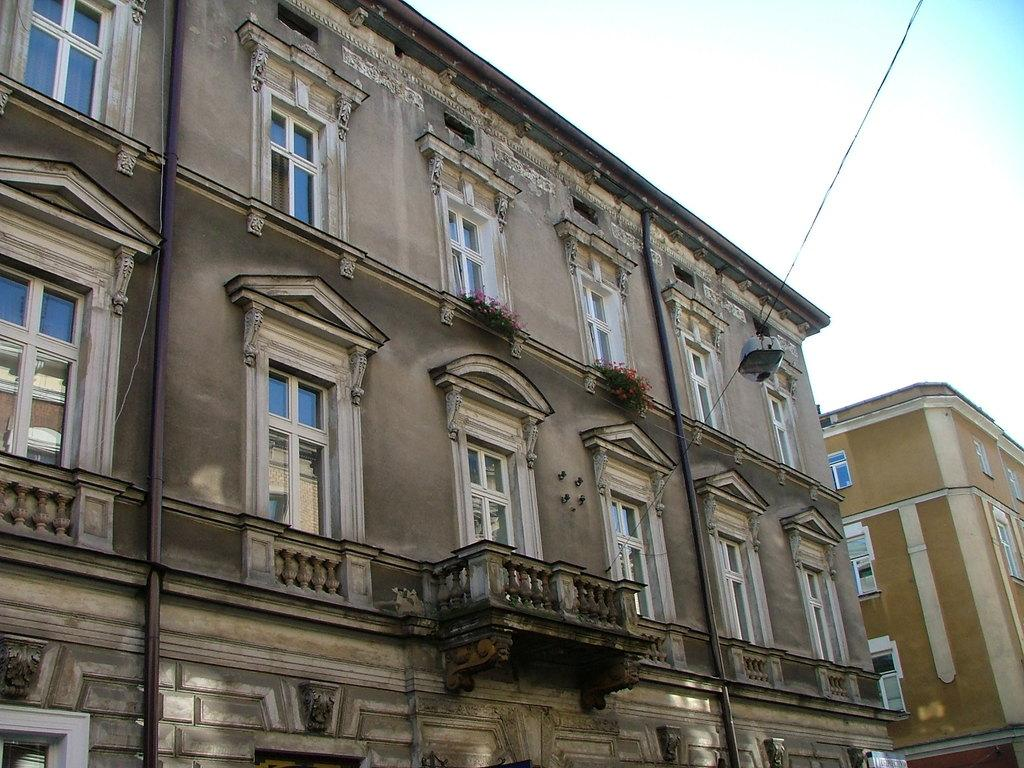What type of structures can be seen in the image? There are buildings in the image. What colors are the buildings? The buildings are in brown and cream colors. What architectural features can be observed on the buildings? There are windows visible on the buildings. What type of vegetation is present in the image? There are plants in the image. What color are the plants? The plants are green in color. What is visible in the background of the image? The sky is visible in the image. What colors make up the sky in the image? The sky is a combination of white and blue colors. Can you tell me how many quills are used to write on the buildings in the image? There are no quills present in the image, and they are not used to write on the buildings. What type of reward is given to the plants in the image? There is no reward given to the plants in the image; they are simply plants. 